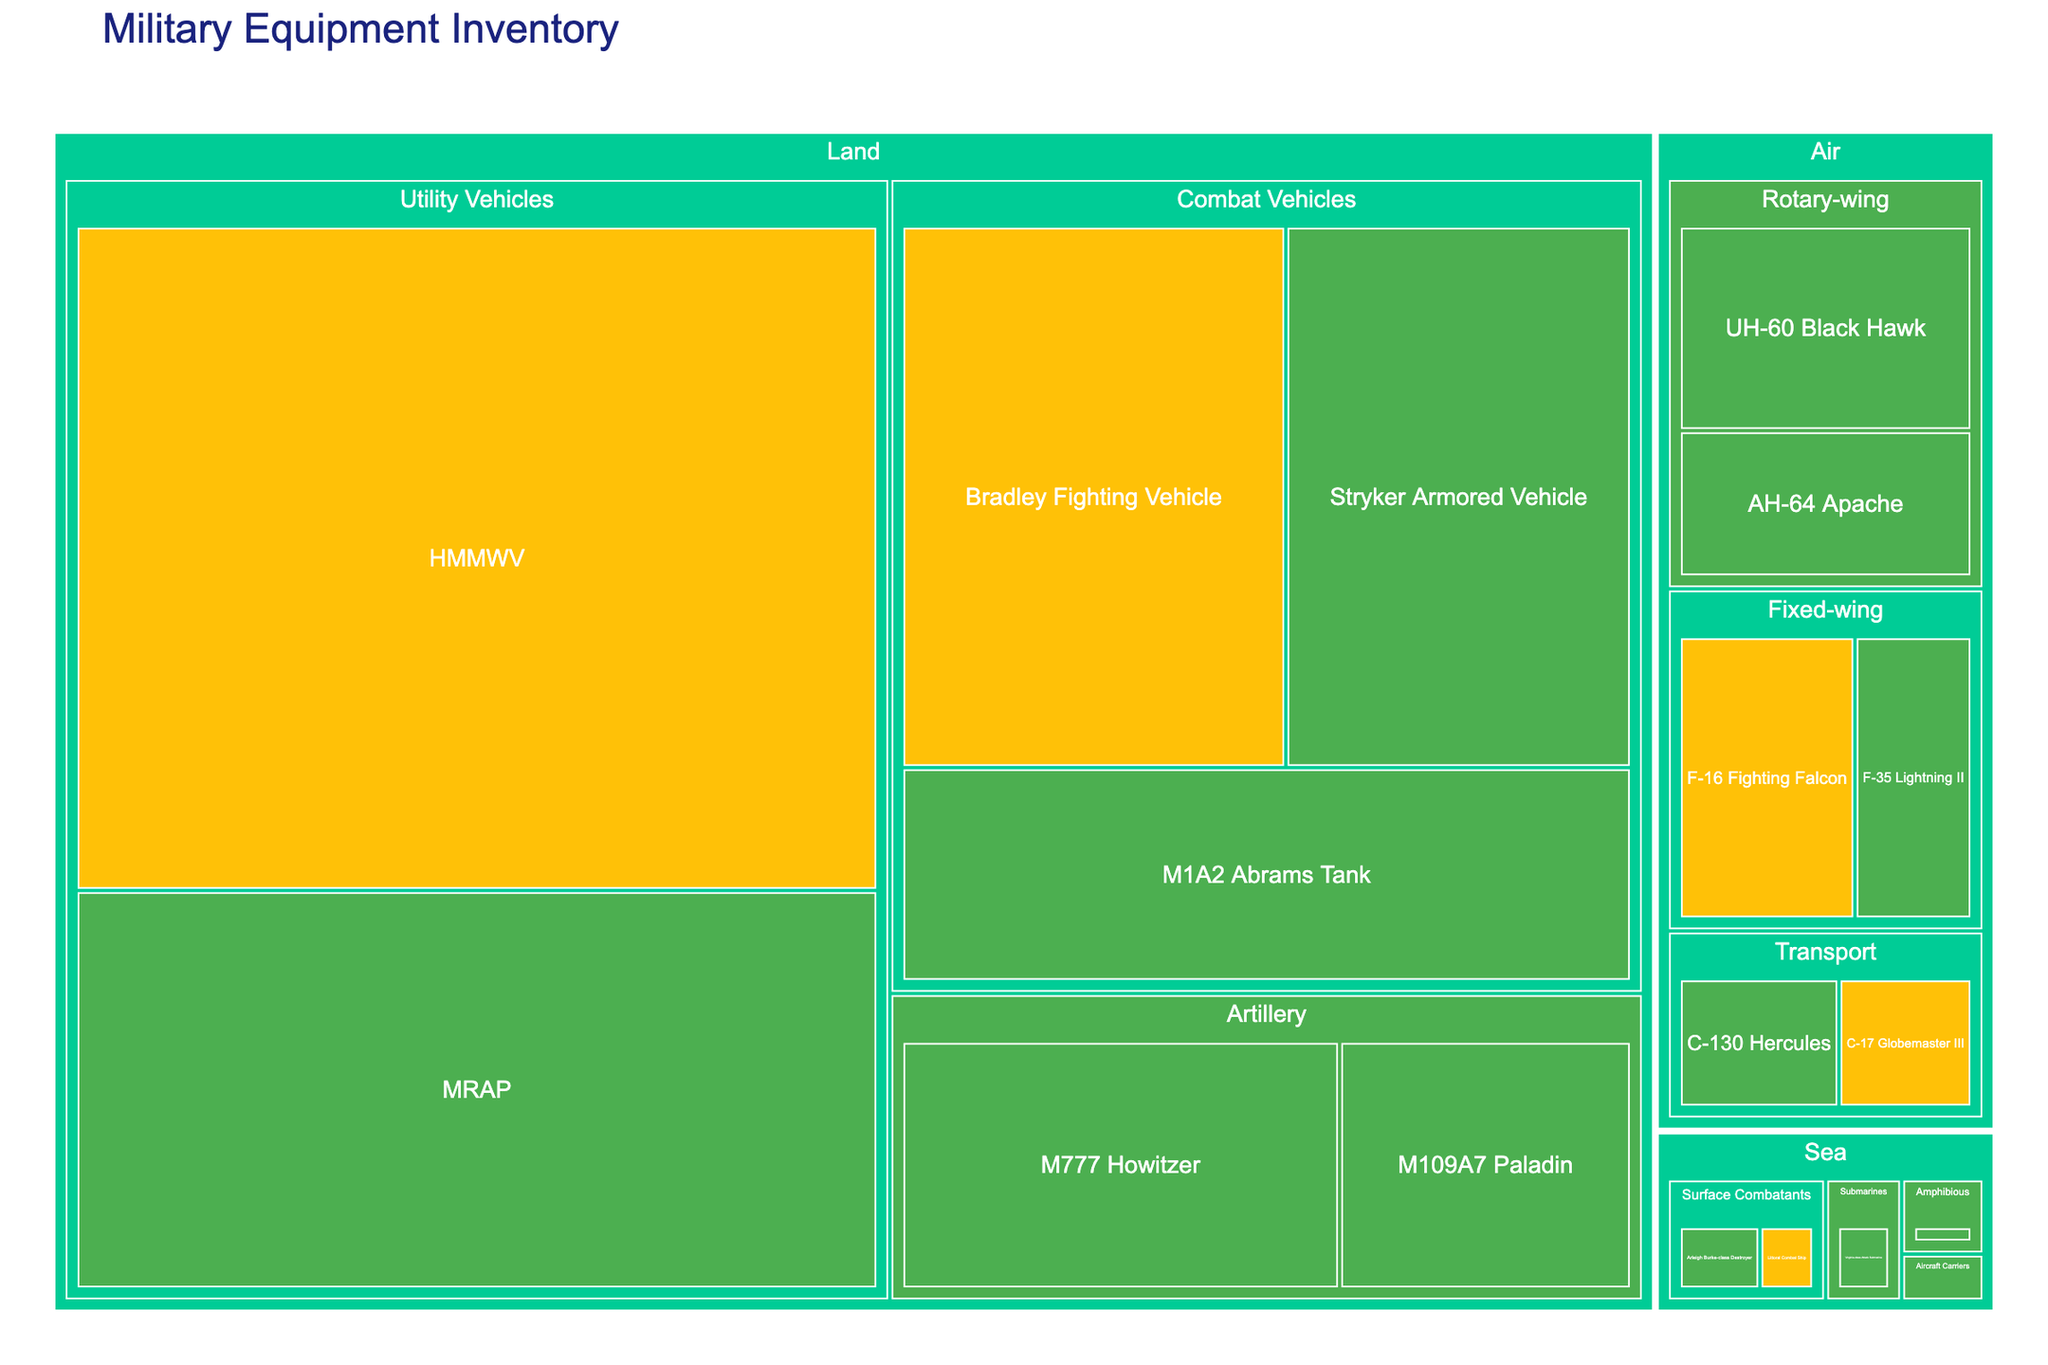What is the title of the Treemap? The title of a plot is typically displayed at the top of the figure. Look at the topmost part of the Treemap; it will state the main subject of the visual.
Answer: Military Equipment Inventory Which type of equipment has the highest count among land combat vehicles? Locate the "Land" category and then look for the "Combat Vehicles" subcategory. Compare the counts of the M1A2 Abrams Tank, Bradley Fighting Vehicle, and Stryker Armored Vehicle.
Answer: Bradley Fighting Vehicle How many types of aircraft are fully operational? Find the "Air" category and note the equipment under "Fixed-wing," "Rotary-wing," and "Transport." Then, count the types marked as "Fully Operational."
Answer: 4 What's the total count of equipment under the "Sea" category? Check the "Sea" category on the Treemap and sum the counts of all its subcategories: Surface Combatants, Amphibious, Submarines, and Aircraft Carriers.
Answer: 50 Which category, land, air, or sea, has the fewest pieces of equipment? Compare the total counts under "Land," "Air," and "Sea" categories by summing the respective counts.
Answer: Sea Which type of equipment in the "Air" category is partially operational with the highest count? Within the "Air" category, find the equipment marked "Partially Operational" and compare their counts.
Answer: F-16 Fighting Falcon Compare the number of fully operational transport aircraft to partially operational transport aircraft. Which is greater? Locate the "Air" category and check the "Transport" subcategory. Compare the counts of fully operational (C-130 Hercules) and partially operational (C-17 Globemaster III).
Answer: Fully operational In the "Land" category, what is the difference in count between fully operational and partially operational utility vehicles? Check the "Land" category for "Utility Vehicles," then find the difference between the counts of fully operational (MRAP) and partially operational (HMMWV).
Answer: 200 What percentage of the total equipment is made up of transport aircraft? Add the counts of C-130 Hercules and C-17 Globemaster III, and then divide by the total sum of all equipment counts. Multiply the result by 100 to get the percentage.
Answer: 3.1% Which category has more pieces of fully operational equipment: artillery in land or rotary-wing in air? Compare the fully operational counts in the "Artillery" subcategory of "Land" with the "Rotary-wing" subcategory of "Air."
Answer: Land artillery 